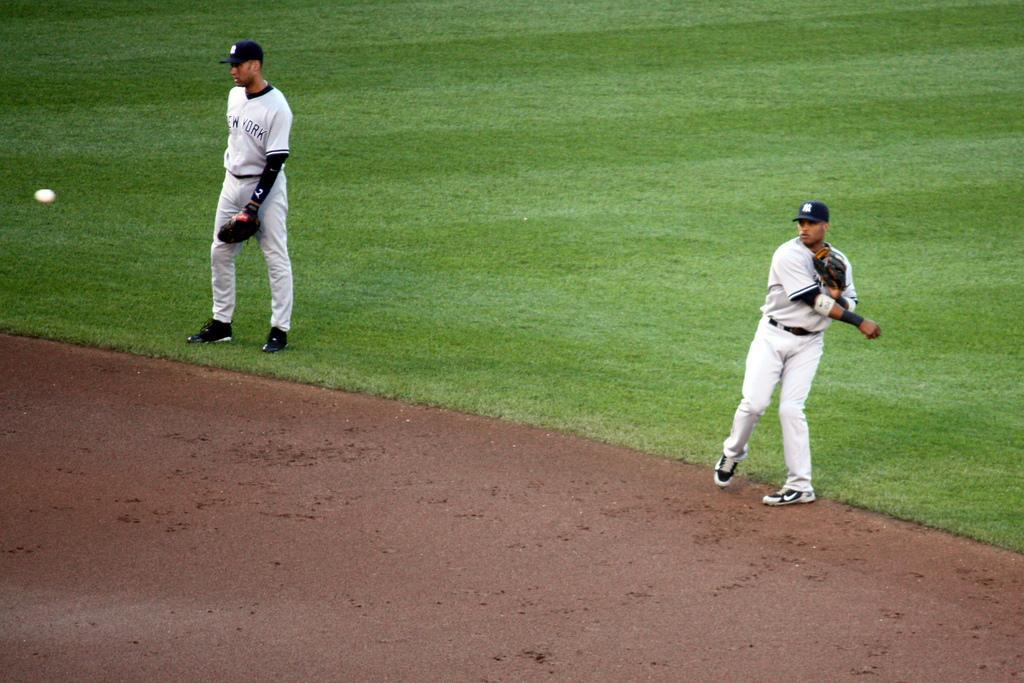How would you summarize this image in a sentence or two? In the foreground, I can see two persons are walking on grass and I can see a ball. This image taken, maybe on the field. 